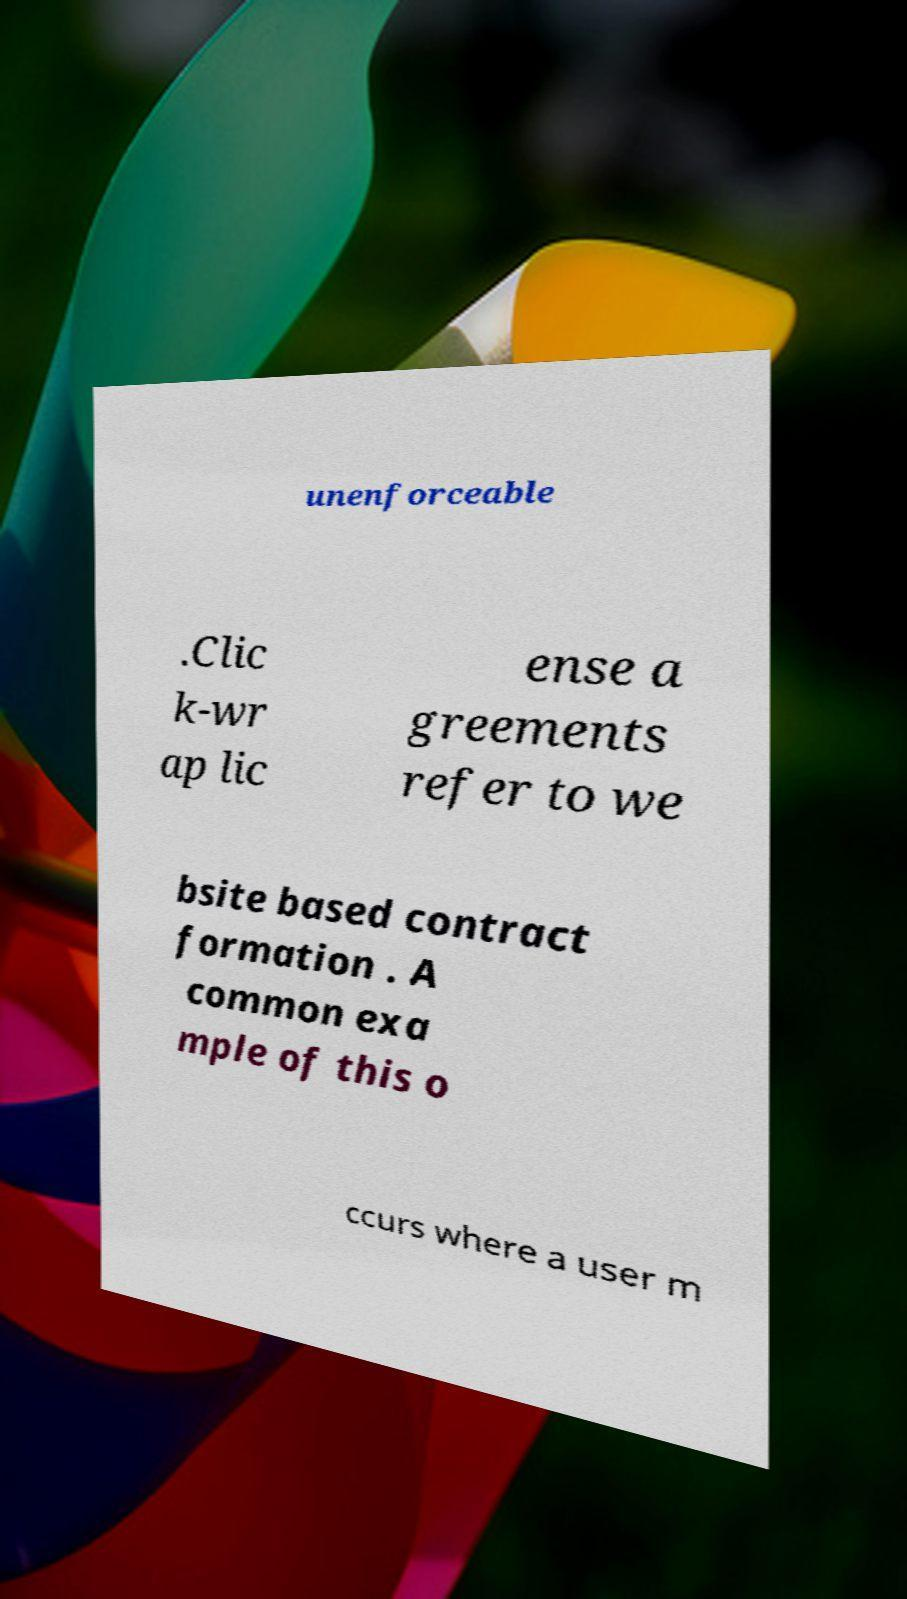Can you accurately transcribe the text from the provided image for me? unenforceable .Clic k-wr ap lic ense a greements refer to we bsite based contract formation . A common exa mple of this o ccurs where a user m 